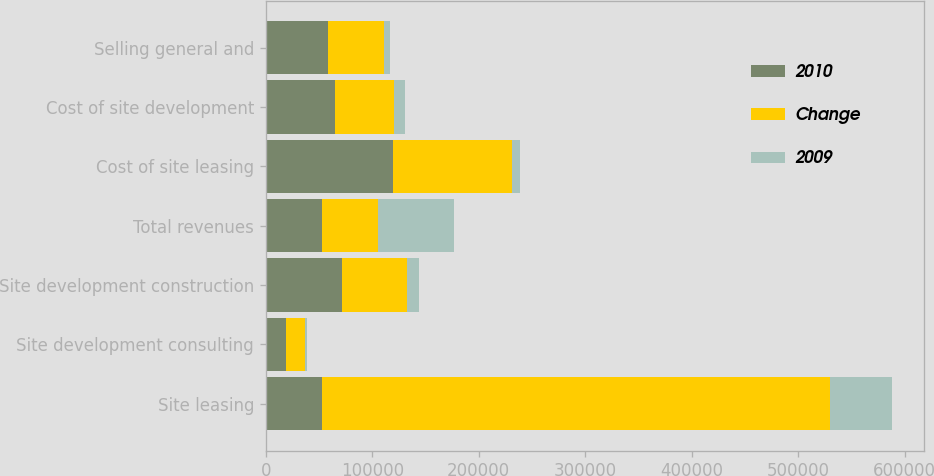<chart> <loc_0><loc_0><loc_500><loc_500><stacked_bar_chart><ecel><fcel>Site leasing<fcel>Site development consulting<fcel>Site development construction<fcel>Total revenues<fcel>Cost of site leasing<fcel>Cost of site development<fcel>Selling general and<nl><fcel>2010<fcel>52785<fcel>19210<fcel>71965<fcel>52785<fcel>119141<fcel>65326<fcel>58209<nl><fcel>Change<fcel>477007<fcel>17408<fcel>61098<fcel>52785<fcel>111842<fcel>55467<fcel>52785<nl><fcel>2009<fcel>58437<fcel>1802<fcel>10867<fcel>71106<fcel>7299<fcel>9859<fcel>5424<nl></chart> 